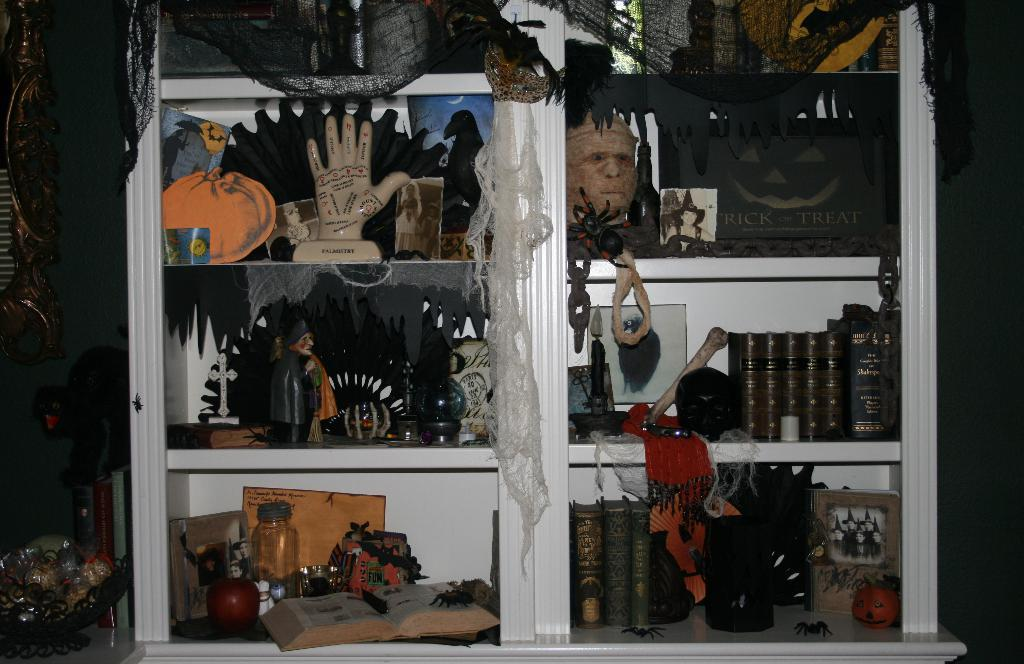What type of furniture is present in the image? There are shelves in the image. What can be found on the shelves? There are objects on the shelves. What else can be seen on the left side of the image? There are other objects on the left side of the image. What type of items are present among the objects in the image? There are books in the image. Can you see a dog using a hydrant in the image? There is no dog or hydrant present in the image. 